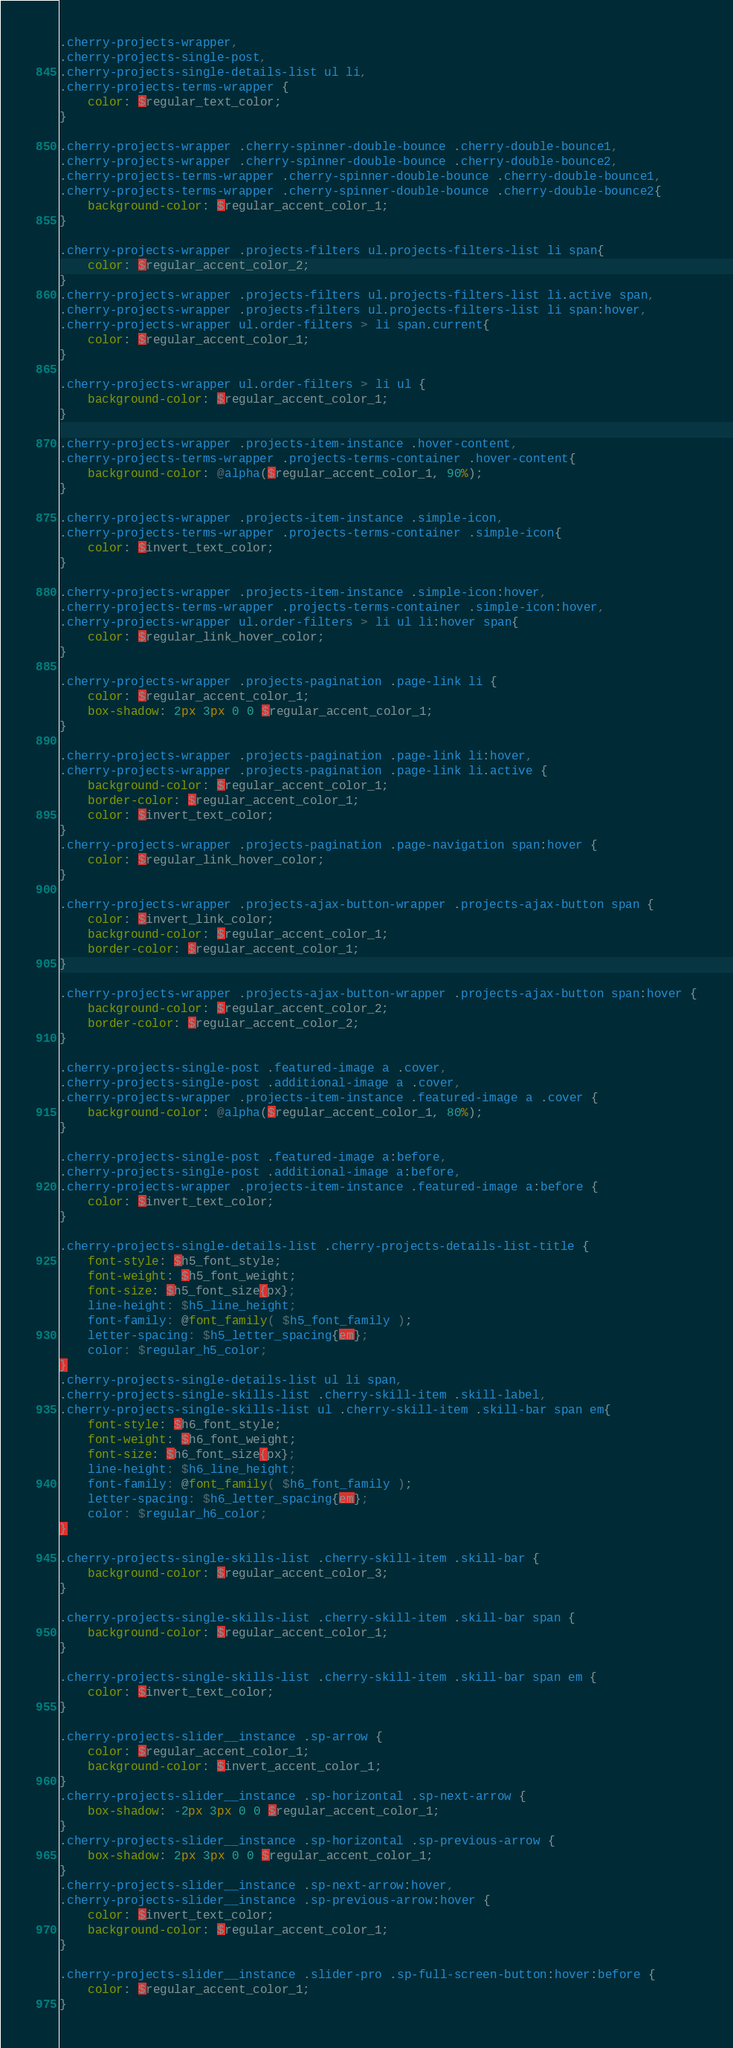<code> <loc_0><loc_0><loc_500><loc_500><_CSS_>.cherry-projects-wrapper,
.cherry-projects-single-post,
.cherry-projects-single-details-list ul li,
.cherry-projects-terms-wrapper {
	color: $regular_text_color;
}

.cherry-projects-wrapper .cherry-spinner-double-bounce .cherry-double-bounce1,
.cherry-projects-wrapper .cherry-spinner-double-bounce .cherry-double-bounce2,
.cherry-projects-terms-wrapper .cherry-spinner-double-bounce .cherry-double-bounce1,
.cherry-projects-terms-wrapper .cherry-spinner-double-bounce .cherry-double-bounce2{
	background-color: $regular_accent_color_1;
}

.cherry-projects-wrapper .projects-filters ul.projects-filters-list li span{
	color: $regular_accent_color_2;
}
.cherry-projects-wrapper .projects-filters ul.projects-filters-list li.active span,
.cherry-projects-wrapper .projects-filters ul.projects-filters-list li span:hover,
.cherry-projects-wrapper ul.order-filters > li span.current{
	color: $regular_accent_color_1;
}

.cherry-projects-wrapper ul.order-filters > li ul {
	background-color: $regular_accent_color_1;
}

.cherry-projects-wrapper .projects-item-instance .hover-content,
.cherry-projects-terms-wrapper .projects-terms-container .hover-content{
	background-color: @alpha($regular_accent_color_1, 90%);
}

.cherry-projects-wrapper .projects-item-instance .simple-icon,
.cherry-projects-terms-wrapper .projects-terms-container .simple-icon{
	color: $invert_text_color;
}

.cherry-projects-wrapper .projects-item-instance .simple-icon:hover,
.cherry-projects-terms-wrapper .projects-terms-container .simple-icon:hover,
.cherry-projects-wrapper ul.order-filters > li ul li:hover span{
	color: $regular_link_hover_color;
}

.cherry-projects-wrapper .projects-pagination .page-link li {
	color: $regular_accent_color_1;
	box-shadow: 2px 3px 0 0 $regular_accent_color_1;
}

.cherry-projects-wrapper .projects-pagination .page-link li:hover,
.cherry-projects-wrapper .projects-pagination .page-link li.active {
	background-color: $regular_accent_color_1;
	border-color: $regular_accent_color_1;
	color: $invert_text_color;
}
.cherry-projects-wrapper .projects-pagination .page-navigation span:hover {
	color: $regular_link_hover_color;
}

.cherry-projects-wrapper .projects-ajax-button-wrapper .projects-ajax-button span {
	color: $invert_link_color;
	background-color: $regular_accent_color_1;
	border-color: $regular_accent_color_1;
}

.cherry-projects-wrapper .projects-ajax-button-wrapper .projects-ajax-button span:hover {
	background-color: $regular_accent_color_2;
	border-color: $regular_accent_color_2;
}

.cherry-projects-single-post .featured-image a .cover,
.cherry-projects-single-post .additional-image a .cover,
.cherry-projects-wrapper .projects-item-instance .featured-image a .cover {
	background-color: @alpha($regular_accent_color_1, 80%);
}

.cherry-projects-single-post .featured-image a:before,
.cherry-projects-single-post .additional-image a:before,
.cherry-projects-wrapper .projects-item-instance .featured-image a:before {
	color: $invert_text_color;
}

.cherry-projects-single-details-list .cherry-projects-details-list-title {
	font-style: $h5_font_style;
	font-weight: $h5_font_weight;
	font-size: $h5_font_size{px};
	line-height: $h5_line_height;
	font-family: @font_family( $h5_font_family );
	letter-spacing: $h5_letter_spacing{em};
	color: $regular_h5_color;
}
.cherry-projects-single-details-list ul li span,
.cherry-projects-single-skills-list .cherry-skill-item .skill-label,
.cherry-projects-single-skills-list ul .cherry-skill-item .skill-bar span em{
	font-style: $h6_font_style;
	font-weight: $h6_font_weight;
	font-size: $h6_font_size{px};
	line-height: $h6_line_height;
	font-family: @font_family( $h6_font_family );
	letter-spacing: $h6_letter_spacing{em};
	color: $regular_h6_color;
}

.cherry-projects-single-skills-list .cherry-skill-item .skill-bar {
	background-color: $regular_accent_color_3;
}

.cherry-projects-single-skills-list .cherry-skill-item .skill-bar span {
	background-color: $regular_accent_color_1;
}

.cherry-projects-single-skills-list .cherry-skill-item .skill-bar span em {
	color: $invert_text_color;
}

.cherry-projects-slider__instance .sp-arrow {
	color: $regular_accent_color_1;
	background-color: $invert_accent_color_1;
}
.cherry-projects-slider__instance .sp-horizontal .sp-next-arrow {
	box-shadow: -2px 3px 0 0 $regular_accent_color_1;
}
.cherry-projects-slider__instance .sp-horizontal .sp-previous-arrow {
	box-shadow: 2px 3px 0 0 $regular_accent_color_1;
}
.cherry-projects-slider__instance .sp-next-arrow:hover,
.cherry-projects-slider__instance .sp-previous-arrow:hover {
	color: $invert_text_color;
	background-color: $regular_accent_color_1;
}

.cherry-projects-slider__instance .slider-pro .sp-full-screen-button:hover:before {
	color: $regular_accent_color_1;
}
</code> 